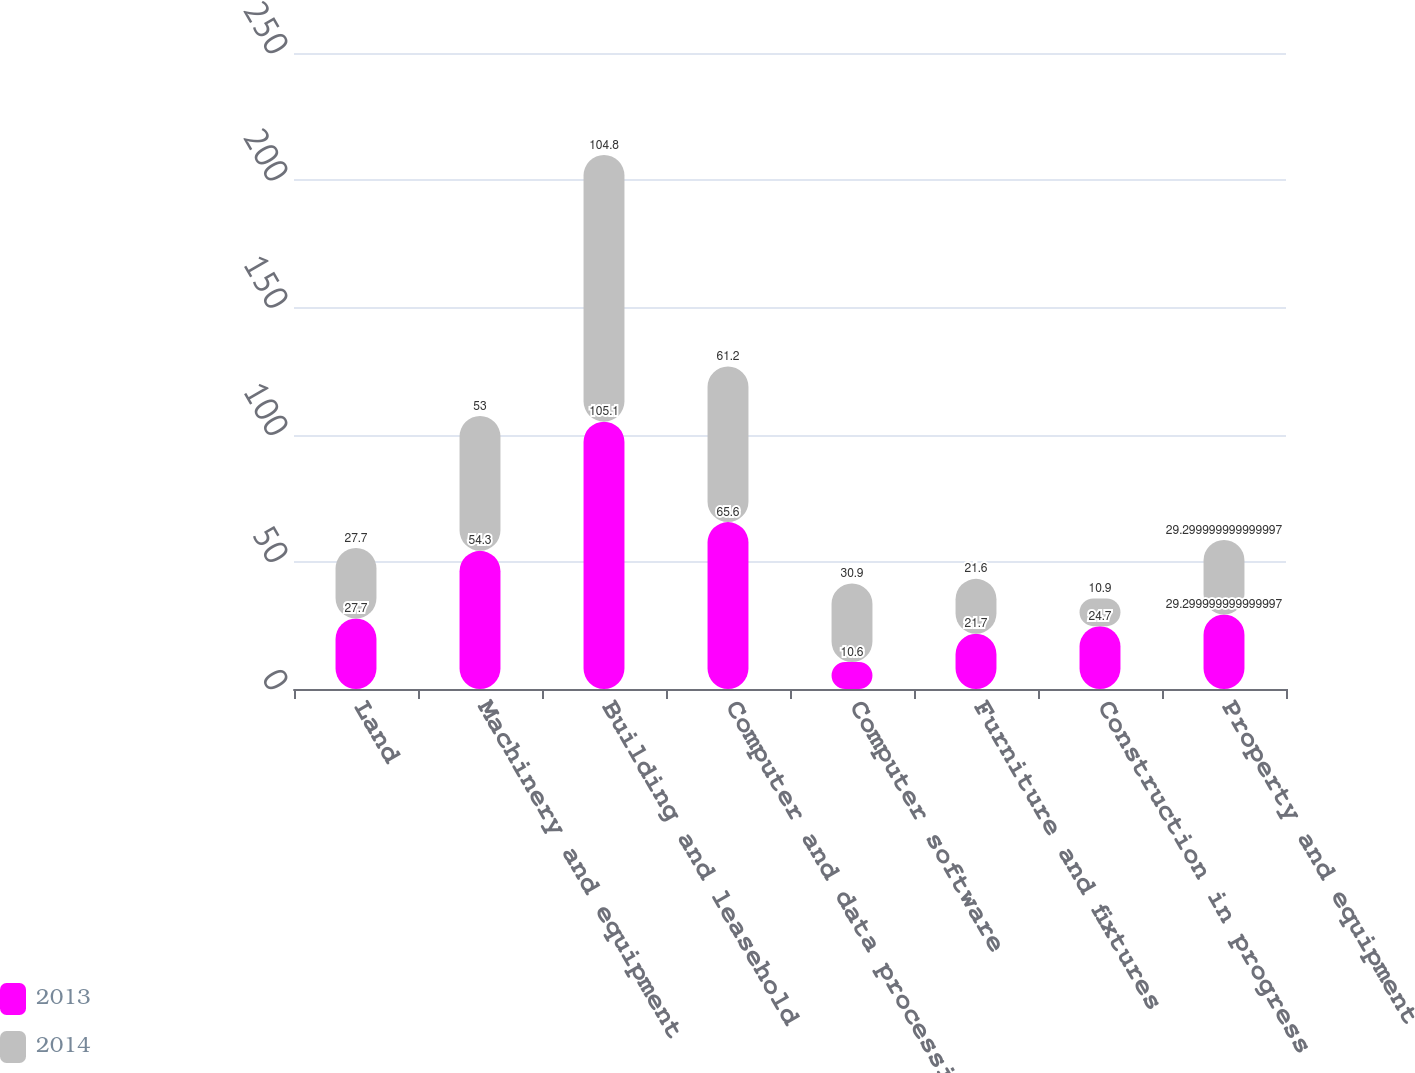<chart> <loc_0><loc_0><loc_500><loc_500><stacked_bar_chart><ecel><fcel>Land<fcel>Machinery and equipment<fcel>Building and leasehold<fcel>Computer and data processing<fcel>Computer software<fcel>Furniture and fixtures<fcel>Construction in progress<fcel>Property and equipment<nl><fcel>2013<fcel>27.7<fcel>54.3<fcel>105.1<fcel>65.6<fcel>10.6<fcel>21.7<fcel>24.7<fcel>29.3<nl><fcel>2014<fcel>27.7<fcel>53<fcel>104.8<fcel>61.2<fcel>30.9<fcel>21.6<fcel>10.9<fcel>29.3<nl></chart> 